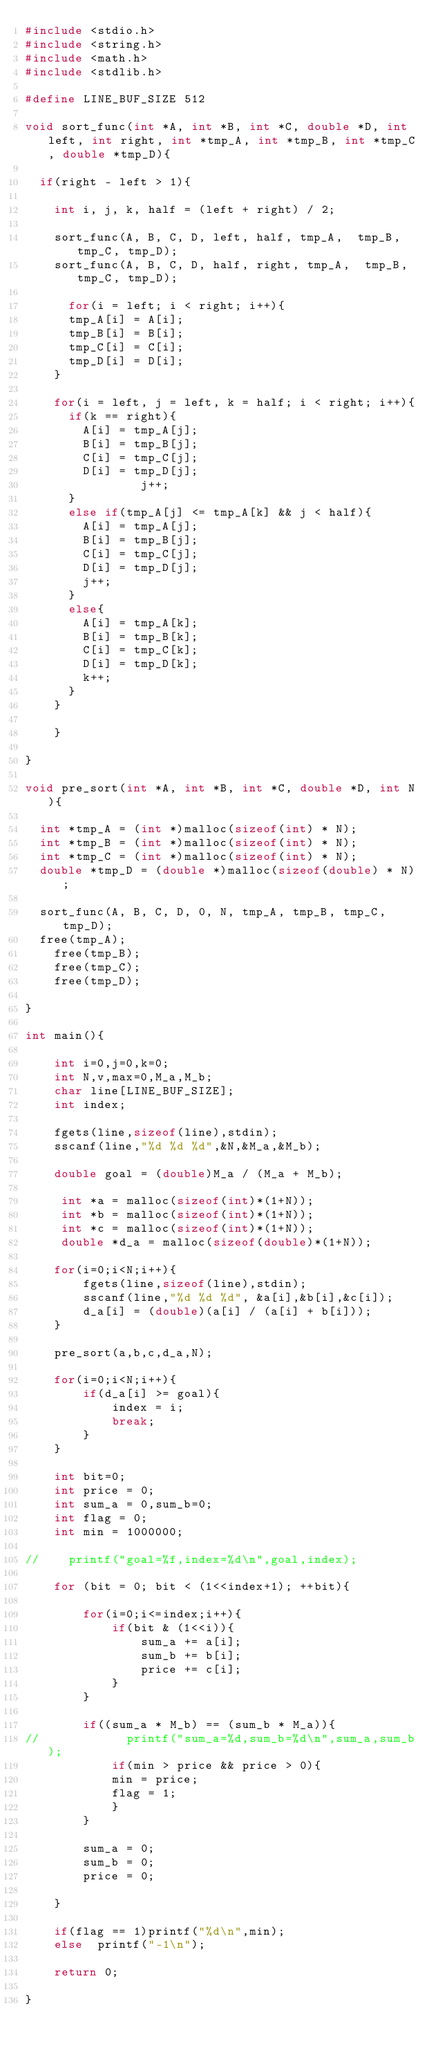<code> <loc_0><loc_0><loc_500><loc_500><_C_>#include <stdio.h>
#include <string.h>
#include <math.h>
#include <stdlib.h>

#define LINE_BUF_SIZE 512

void sort_func(int *A, int *B, int *C, double *D, int left, int right, int *tmp_A, int *tmp_B, int *tmp_C, double *tmp_D){
    
	if(right - left > 1){

		int i, j, k, half = (left + right) / 2;
	
    sort_func(A, B, C, D, left, half, tmp_A,  tmp_B, tmp_C, tmp_D);
    sort_func(A, B, C, D, half, right, tmp_A,  tmp_B, tmp_C, tmp_D);

    	for(i = left; i < right; i++){
			tmp_A[i] = A[i];
			tmp_B[i] = B[i];
			tmp_C[i] = C[i];
			tmp_D[i] = D[i];
		}

		for(i = left, j = left, k = half; i < right; i++){
			if(k == right){
				A[i] = tmp_A[j];
				B[i] = tmp_B[j];
				C[i] = tmp_C[j];
				D[i] = tmp_D[j];
                j++;
			}
			else if(tmp_A[j] <= tmp_A[k] && j < half){
				A[i] = tmp_A[j];
				B[i] = tmp_B[j];
				C[i] = tmp_C[j];
				D[i] = tmp_D[j];
				j++;
			}
			else{
				A[i] = tmp_A[k];
				B[i] = tmp_B[k];
				C[i] = tmp_C[k];
				D[i] = tmp_D[k];
				k++;
			}
		}
	
    }

}

void pre_sort(int *A, int *B, int *C, double *D, int N){

	int *tmp_A = (int *)malloc(sizeof(int) * N);
	int *tmp_B = (int *)malloc(sizeof(int) * N);
	int *tmp_C = (int *)malloc(sizeof(int) * N);
	double *tmp_D = (double *)malloc(sizeof(double) * N);

	sort_func(A, B, C, D, 0, N, tmp_A, tmp_B, tmp_C, tmp_D);
	free(tmp_A);
    free(tmp_B);
    free(tmp_C);
    free(tmp_D);

}

int main(){

    int i=0,j=0,k=0;
    int N,v,max=0,M_a,M_b;
    char line[LINE_BUF_SIZE];
    int index;

    fgets(line,sizeof(line),stdin);
    sscanf(line,"%d %d %d",&N,&M_a,&M_b);

    double goal = (double)M_a / (M_a + M_b);

     int *a = malloc(sizeof(int)*(1+N));
     int *b = malloc(sizeof(int)*(1+N));
     int *c = malloc(sizeof(int)*(1+N));
     double *d_a = malloc(sizeof(double)*(1+N));

    for(i=0;i<N;i++){
        fgets(line,sizeof(line),stdin);
        sscanf(line,"%d %d %d", &a[i],&b[i],&c[i]);
        d_a[i] = (double)(a[i] / (a[i] + b[i]));
    }

    pre_sort(a,b,c,d_a,N);

    for(i=0;i<N;i++){
        if(d_a[i] >= goal){
            index = i;
            break;
        }
    }

    int bit=0;
    int price = 0;
    int sum_a = 0,sum_b=0;
    int flag = 0;
    int min = 1000000;

//    printf("goal=%f,index=%d\n",goal,index);

    for (bit = 0; bit < (1<<index+1); ++bit){
        
        for(i=0;i<=index;i++){
            if(bit & (1<<i)){
                sum_a += a[i];
                sum_b += b[i];
                price += c[i];
            }
        }
        
        if((sum_a * M_b) == (sum_b * M_a)){
//            printf("sum_a=%d,sum_b=%d\n",sum_a,sum_b);
            if(min > price && price > 0){
            min = price;
            flag = 1;
            }
        }
   
        sum_a = 0;
        sum_b = 0;
        price = 0;

    }
    
    if(flag == 1)printf("%d\n",min);
    else  printf("-1\n");

    return 0;

}</code> 